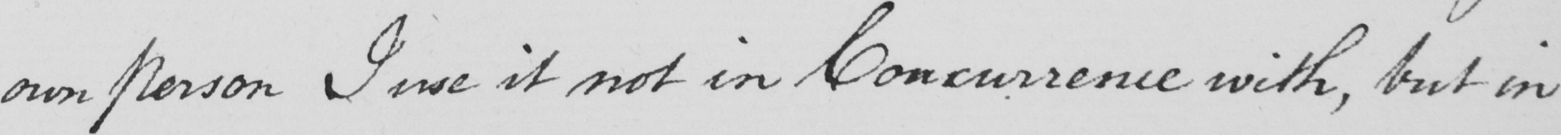Can you tell me what this handwritten text says? own person I use it not in Concurrence with , but in 